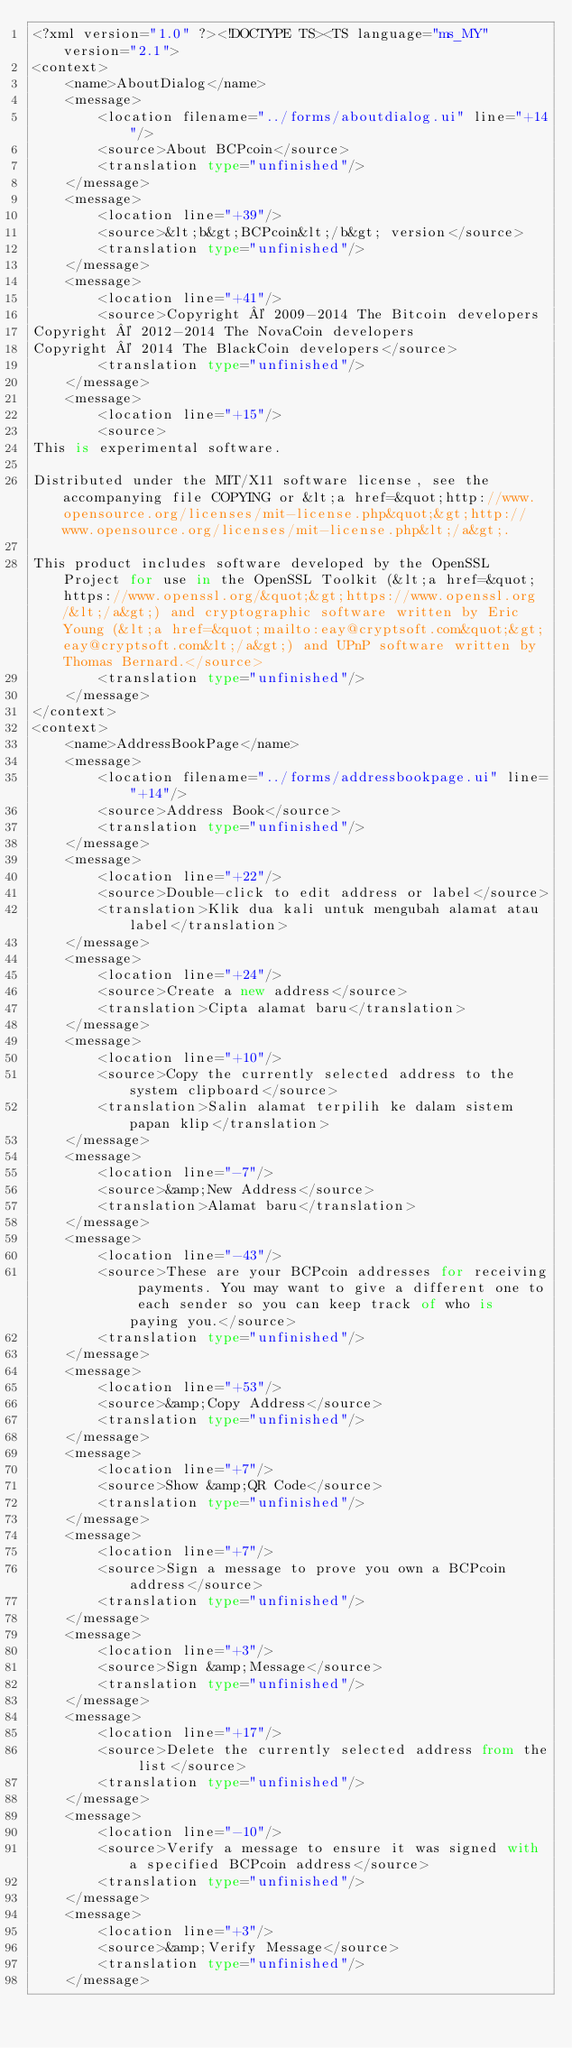<code> <loc_0><loc_0><loc_500><loc_500><_TypeScript_><?xml version="1.0" ?><!DOCTYPE TS><TS language="ms_MY" version="2.1">
<context>
    <name>AboutDialog</name>
    <message>
        <location filename="../forms/aboutdialog.ui" line="+14"/>
        <source>About BCPcoin</source>
        <translation type="unfinished"/>
    </message>
    <message>
        <location line="+39"/>
        <source>&lt;b&gt;BCPcoin&lt;/b&gt; version</source>
        <translation type="unfinished"/>
    </message>
    <message>
        <location line="+41"/>
        <source>Copyright © 2009-2014 The Bitcoin developers
Copyright © 2012-2014 The NovaCoin developers
Copyright © 2014 The BlackCoin developers</source>
        <translation type="unfinished"/>
    </message>
    <message>
        <location line="+15"/>
        <source>
This is experimental software.

Distributed under the MIT/X11 software license, see the accompanying file COPYING or &lt;a href=&quot;http://www.opensource.org/licenses/mit-license.php&quot;&gt;http://www.opensource.org/licenses/mit-license.php&lt;/a&gt;.

This product includes software developed by the OpenSSL Project for use in the OpenSSL Toolkit (&lt;a href=&quot;https://www.openssl.org/&quot;&gt;https://www.openssl.org/&lt;/a&gt;) and cryptographic software written by Eric Young (&lt;a href=&quot;mailto:eay@cryptsoft.com&quot;&gt;eay@cryptsoft.com&lt;/a&gt;) and UPnP software written by Thomas Bernard.</source>
        <translation type="unfinished"/>
    </message>
</context>
<context>
    <name>AddressBookPage</name>
    <message>
        <location filename="../forms/addressbookpage.ui" line="+14"/>
        <source>Address Book</source>
        <translation type="unfinished"/>
    </message>
    <message>
        <location line="+22"/>
        <source>Double-click to edit address or label</source>
        <translation>Klik dua kali untuk mengubah alamat atau label</translation>
    </message>
    <message>
        <location line="+24"/>
        <source>Create a new address</source>
        <translation>Cipta alamat baru</translation>
    </message>
    <message>
        <location line="+10"/>
        <source>Copy the currently selected address to the system clipboard</source>
        <translation>Salin alamat terpilih ke dalam sistem papan klip</translation>
    </message>
    <message>
        <location line="-7"/>
        <source>&amp;New Address</source>
        <translation>Alamat baru</translation>
    </message>
    <message>
        <location line="-43"/>
        <source>These are your BCPcoin addresses for receiving payments. You may want to give a different one to each sender so you can keep track of who is paying you.</source>
        <translation type="unfinished"/>
    </message>
    <message>
        <location line="+53"/>
        <source>&amp;Copy Address</source>
        <translation type="unfinished"/>
    </message>
    <message>
        <location line="+7"/>
        <source>Show &amp;QR Code</source>
        <translation type="unfinished"/>
    </message>
    <message>
        <location line="+7"/>
        <source>Sign a message to prove you own a BCPcoin address</source>
        <translation type="unfinished"/>
    </message>
    <message>
        <location line="+3"/>
        <source>Sign &amp;Message</source>
        <translation type="unfinished"/>
    </message>
    <message>
        <location line="+17"/>
        <source>Delete the currently selected address from the list</source>
        <translation type="unfinished"/>
    </message>
    <message>
        <location line="-10"/>
        <source>Verify a message to ensure it was signed with a specified BCPcoin address</source>
        <translation type="unfinished"/>
    </message>
    <message>
        <location line="+3"/>
        <source>&amp;Verify Message</source>
        <translation type="unfinished"/>
    </message></code> 